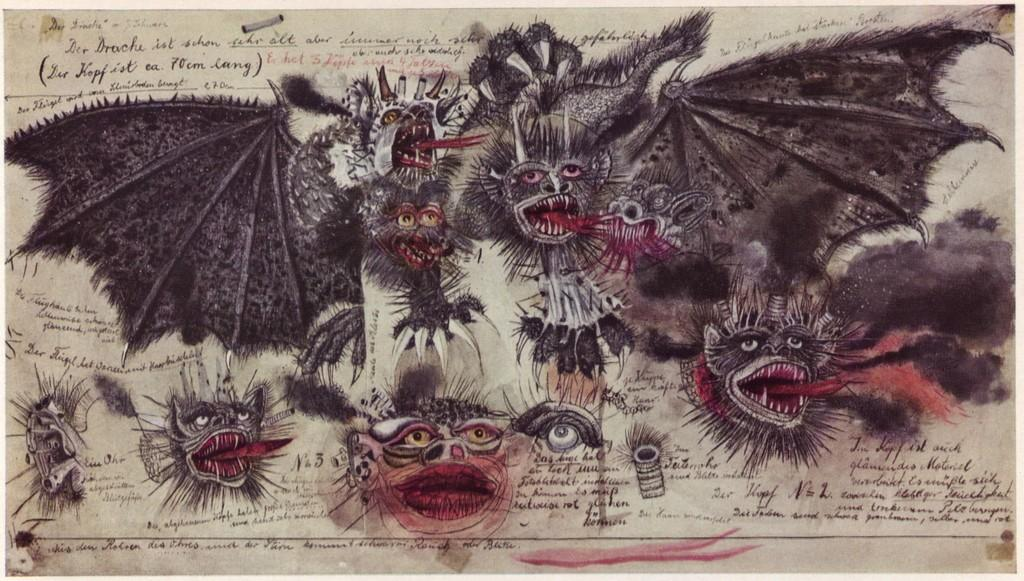What is present in the image that has both images and text? There is a paper in the image that has images and text on it. Can you describe the images on the paper? Unfortunately, the specific images on the paper cannot be described without more information. What type of information might be conveyed by the text on the paper? The text on the paper could convey various types of information, such as instructions, a story, or a message. Where is the maid standing in the image? There is no maid present in the image. What type of gate is visible in the image? There is no gate present in the image. 